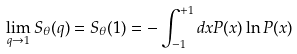Convert formula to latex. <formula><loc_0><loc_0><loc_500><loc_500>\lim _ { q \rightarrow 1 } S _ { \theta } ( q ) = S _ { \theta } ( 1 ) = - \int _ { - 1 } ^ { + 1 } d x P ( x ) \ln P ( x )</formula> 